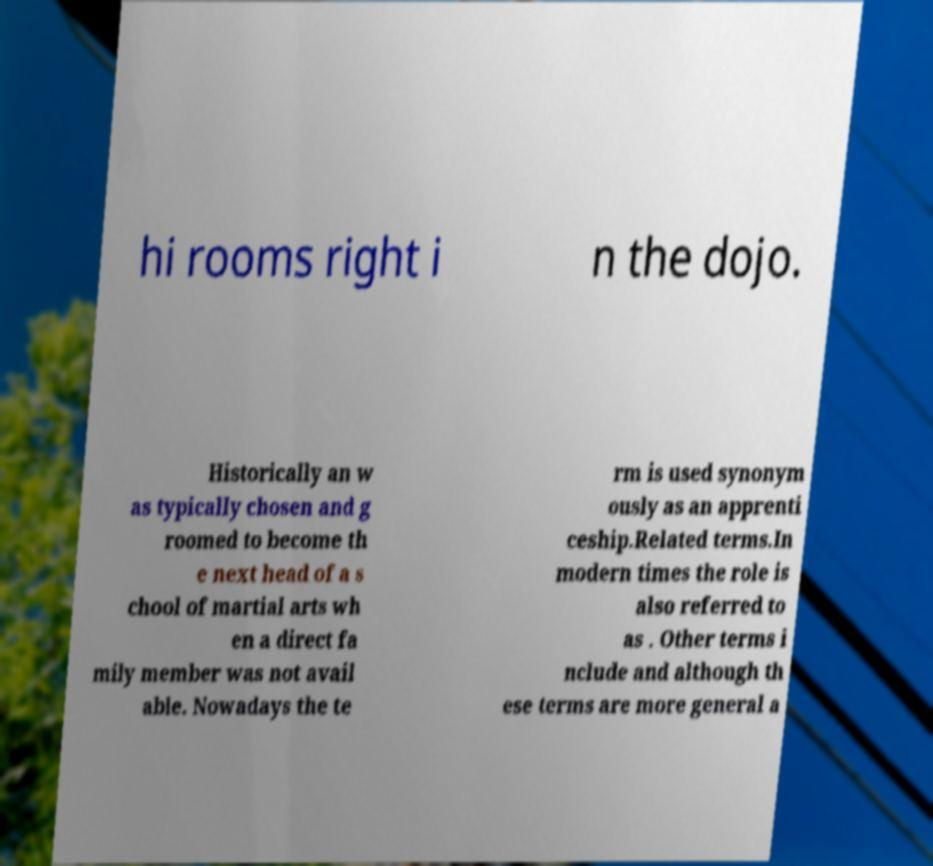What messages or text are displayed in this image? I need them in a readable, typed format. hi rooms right i n the dojo. Historically an w as typically chosen and g roomed to become th e next head of a s chool of martial arts wh en a direct fa mily member was not avail able. Nowadays the te rm is used synonym ously as an apprenti ceship.Related terms.In modern times the role is also referred to as . Other terms i nclude and although th ese terms are more general a 